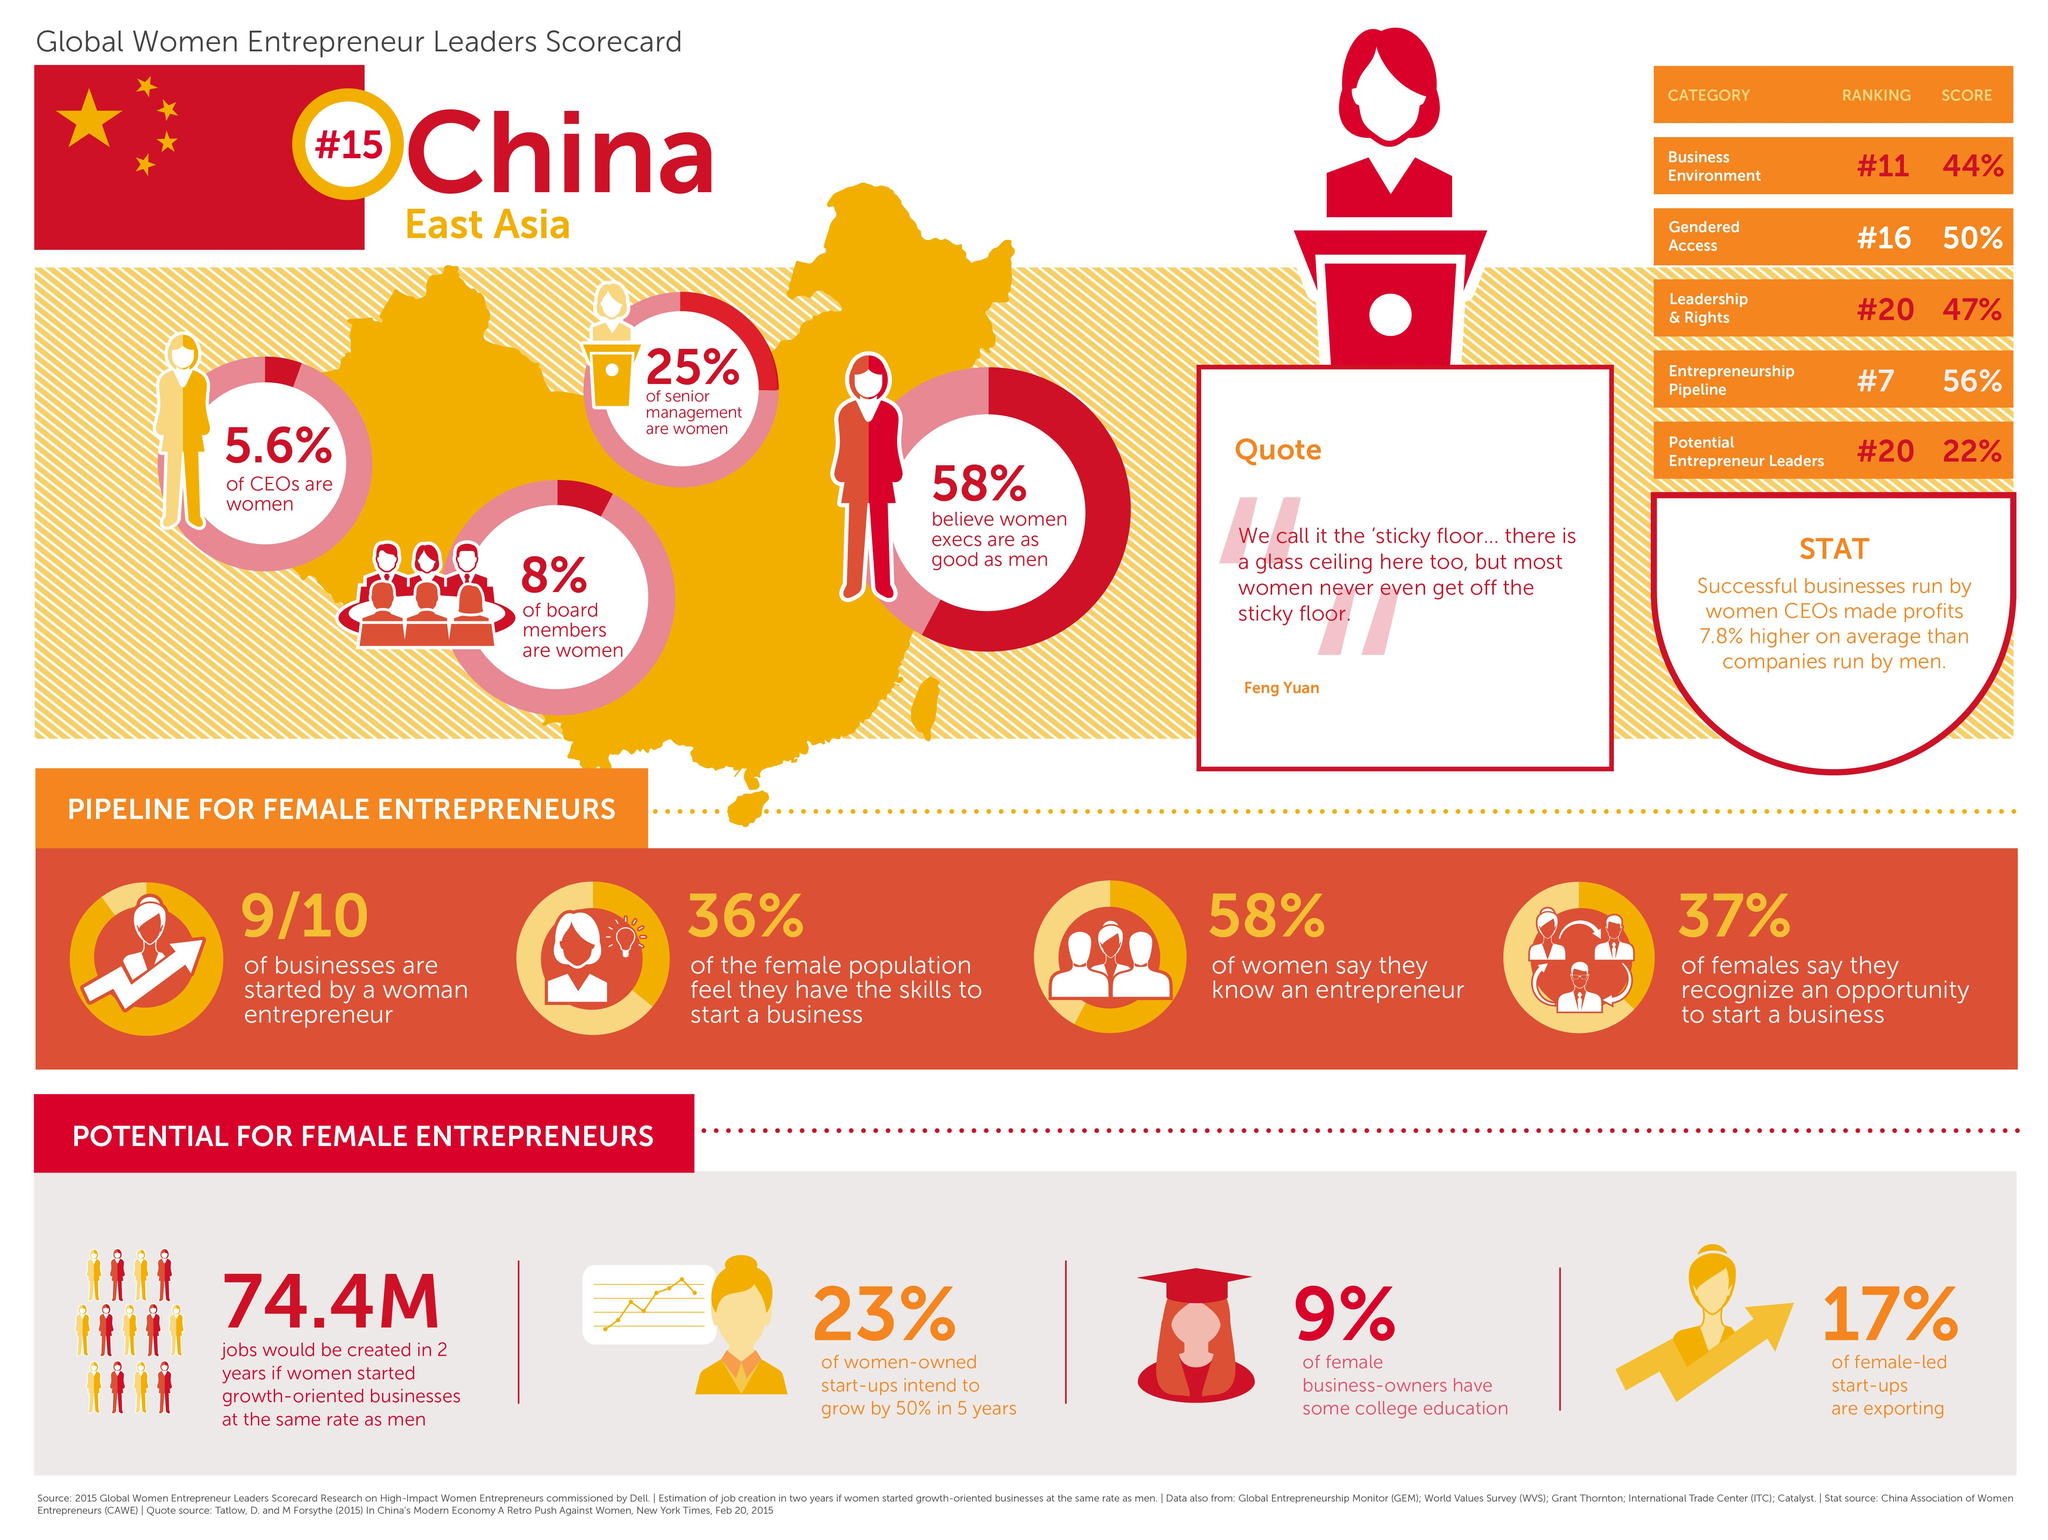Give some essential details in this illustration. It is estimated that only 9% of women entrepreneurs hold a college education. According to a recent study, 23% of women-owned startups plan to experience a 50% growth in the next five years. Thirty-six percent of women believe they have the skills necessary to start a business. Ninety percent of the businesses launched are launched by a woman entrepreneur. According to the report, 37% of the women surveyed stated that they can identify a business opportunity. 